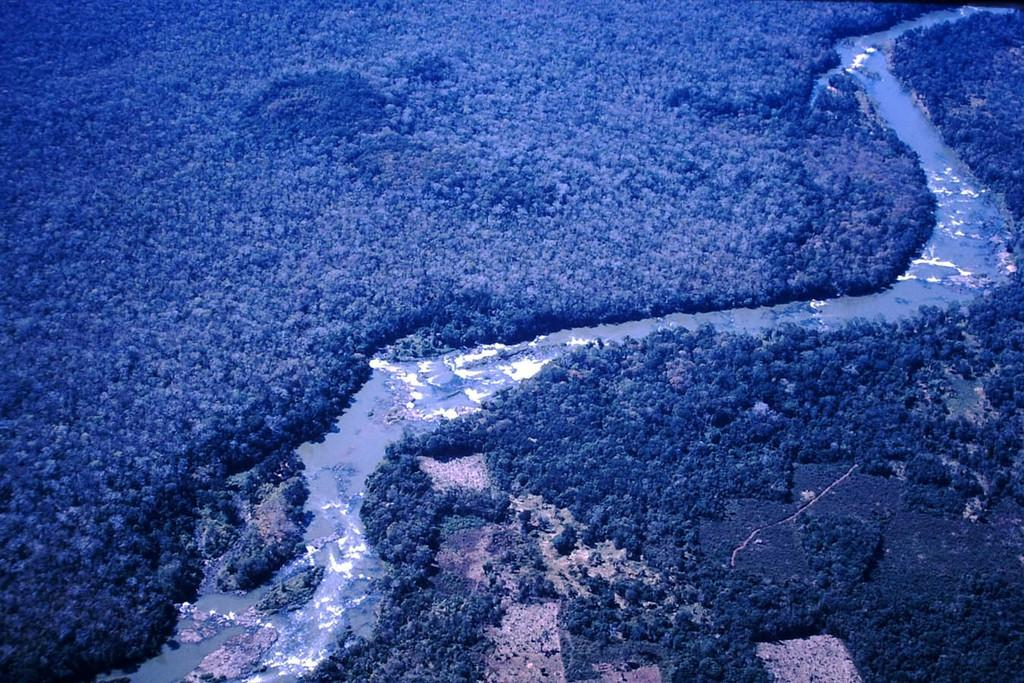What type of natural feature is present in the image? There is a river in the image. What can be seen in the surroundings of the river? There is greenery in the image. What type of objects are present in the river? There are stones in the image. What company is responsible for the stones in the image? There is no company mentioned or implied in the image; it simply shows a river with stones. 